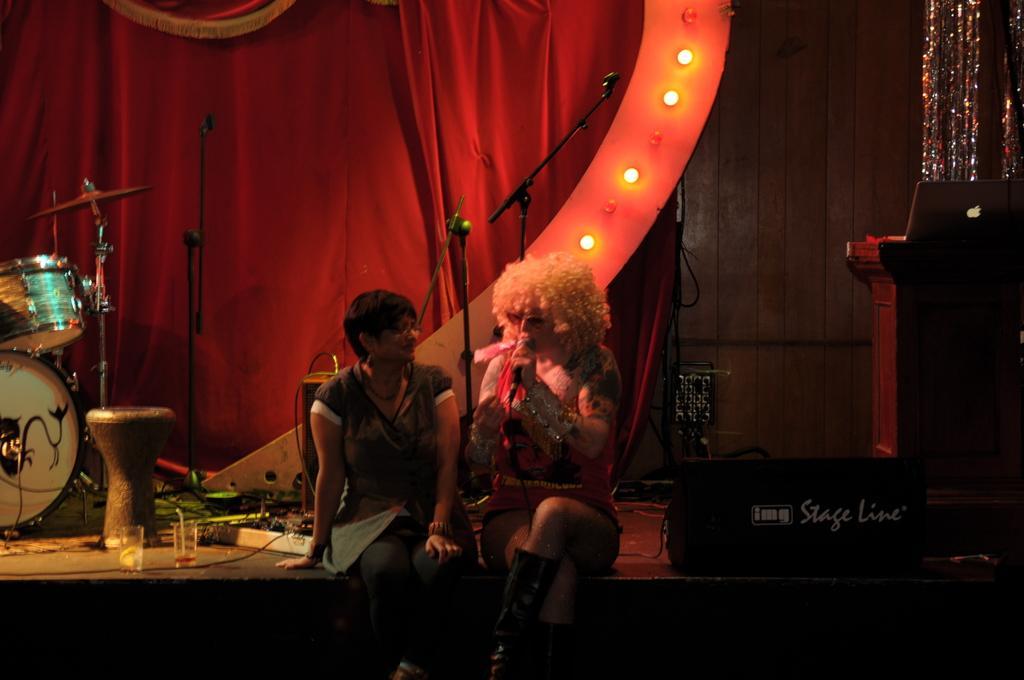In one or two sentences, can you explain what this image depicts? In the foreground of this image, there are two women sitting on the stage and a woman is holding a mic. Beside her, there is a light. On the right, there is a podium on which a laptop. In the background, there are lights, curtains, mic stands, switch board, two glasses on the floor and the drums. 